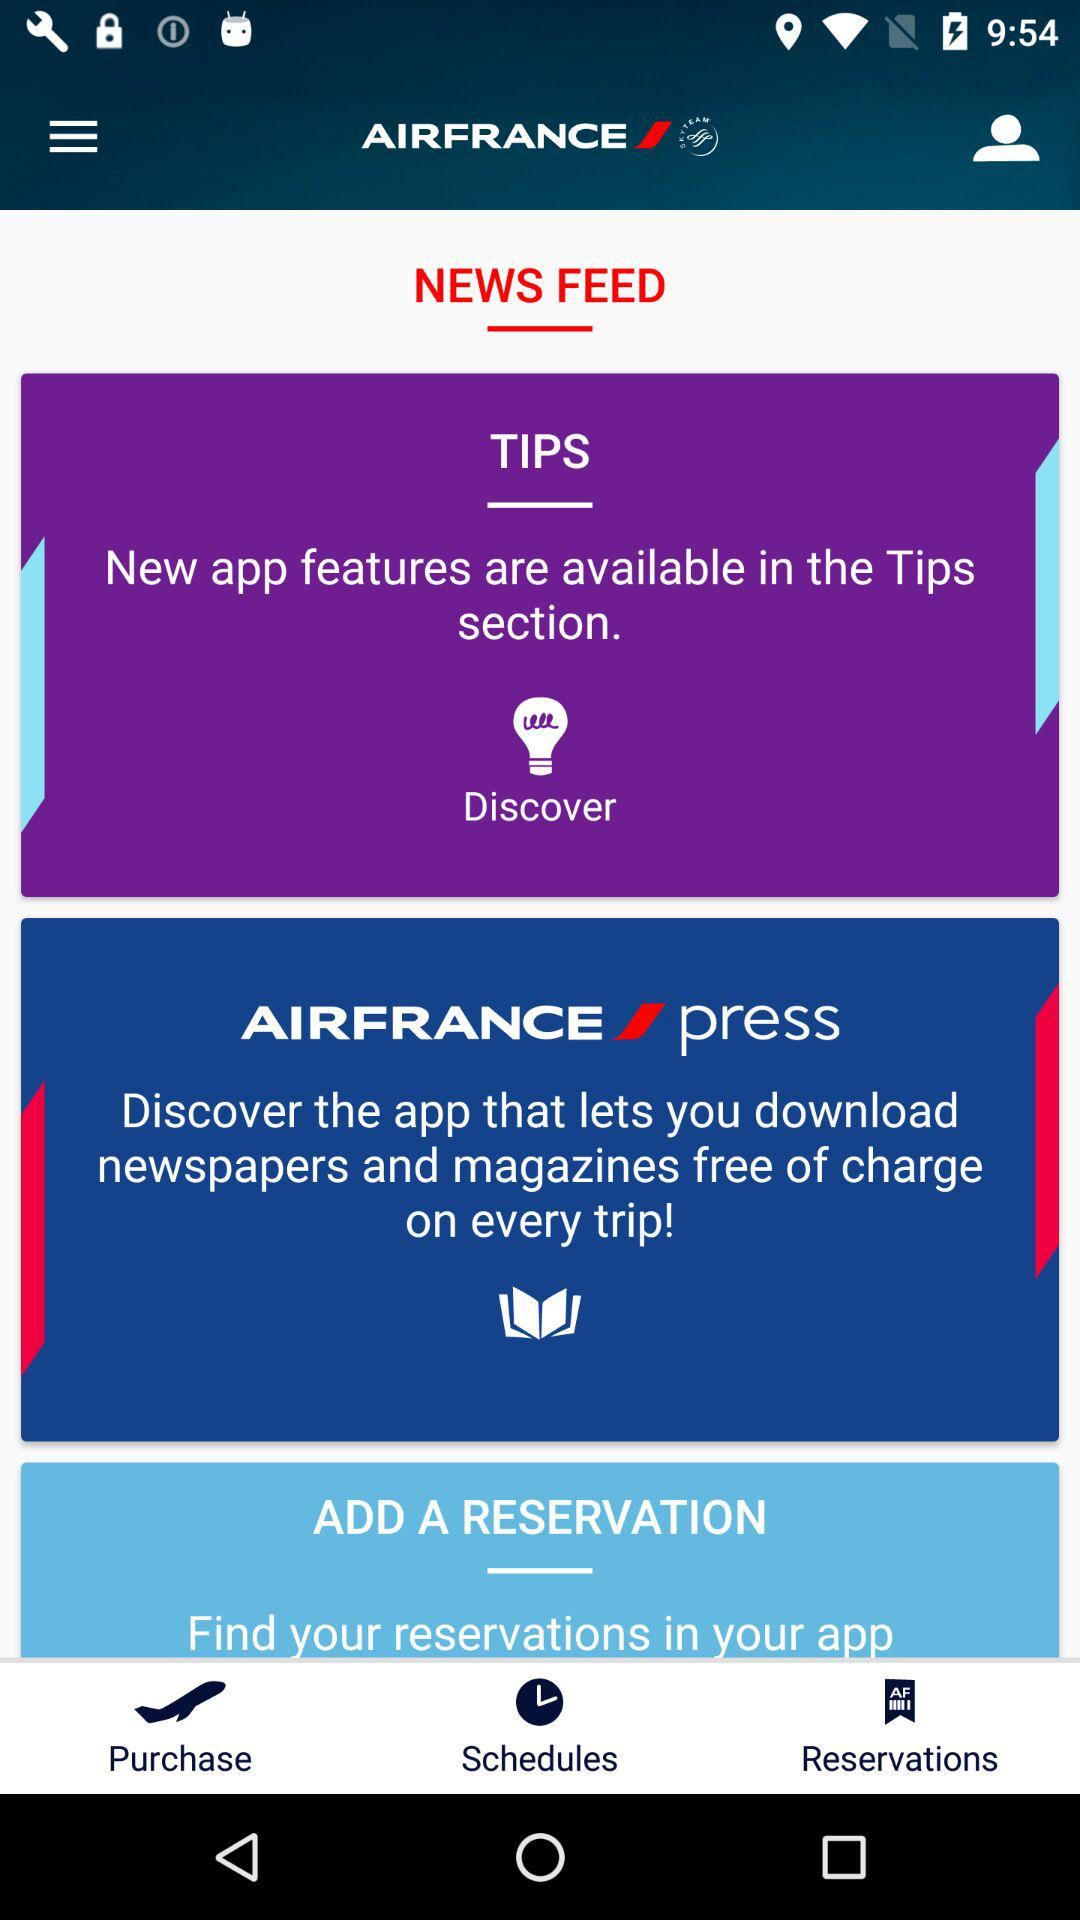What is the name of the application? The application name is "AIRFRANCE". 